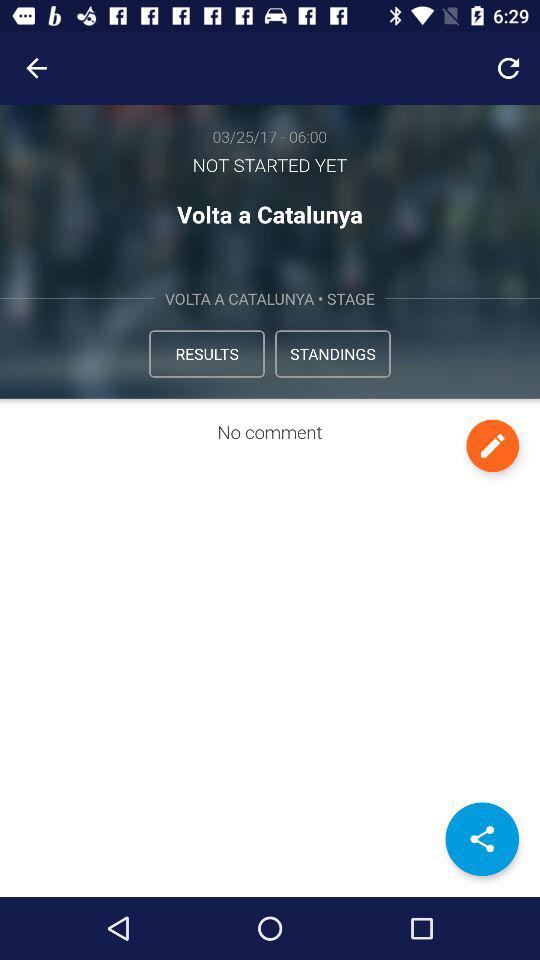What is the date of "Volta a Catalunya"? The date is March 25, 2017. 